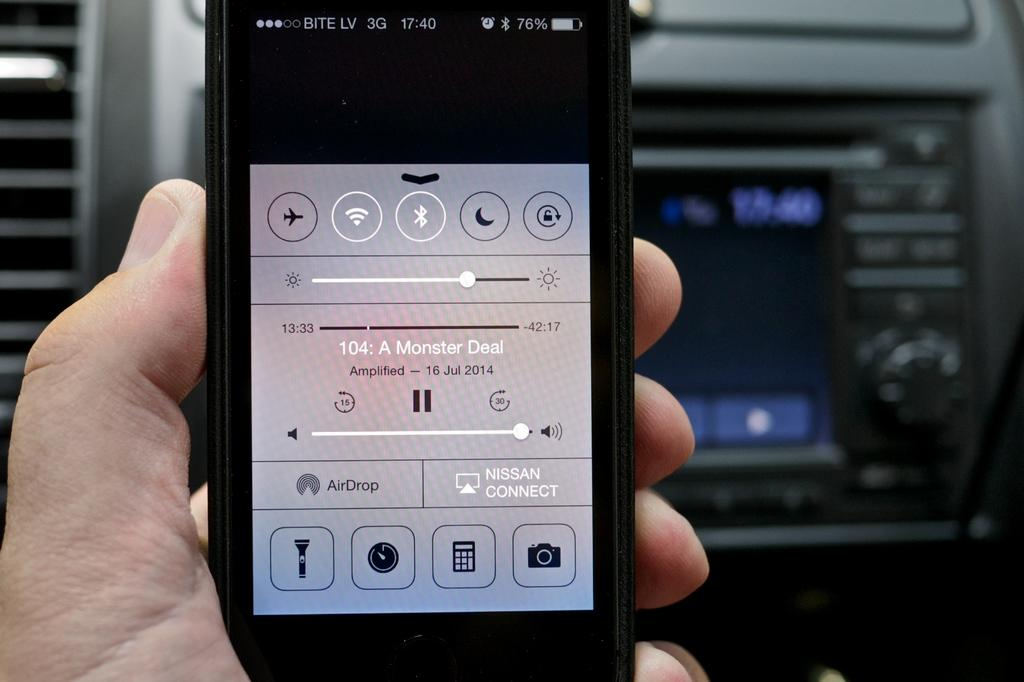<image>
Summarize the visual content of the image. A black phone with the menu pulled up and it is visible that something titled 104: A Monster Deal is being listened to. 